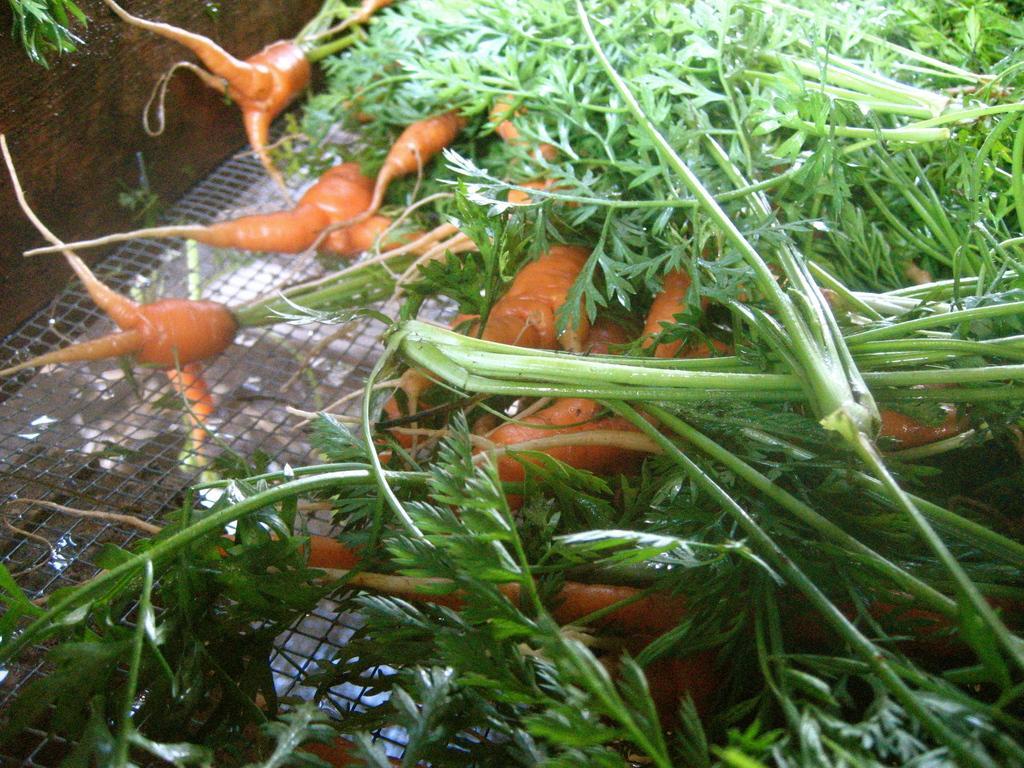Could you give a brief overview of what you see in this image? In this picture I can see some carrots to the plants. 